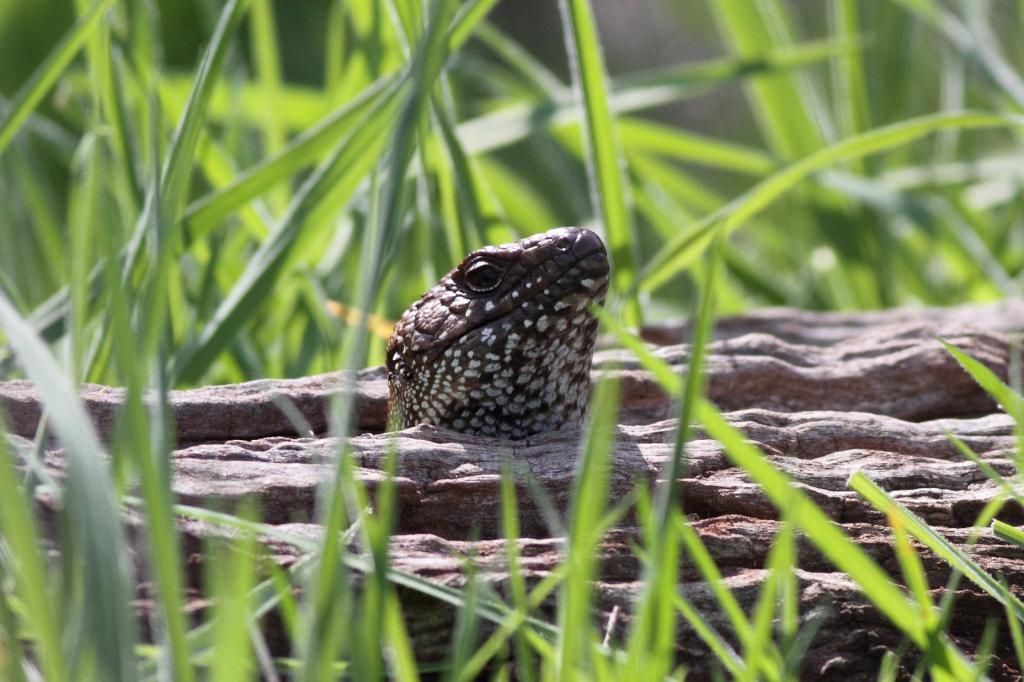Could you give a brief overview of what you see in this image? In this image in the center there is a snake, and in the foreground and background there are some plants. 